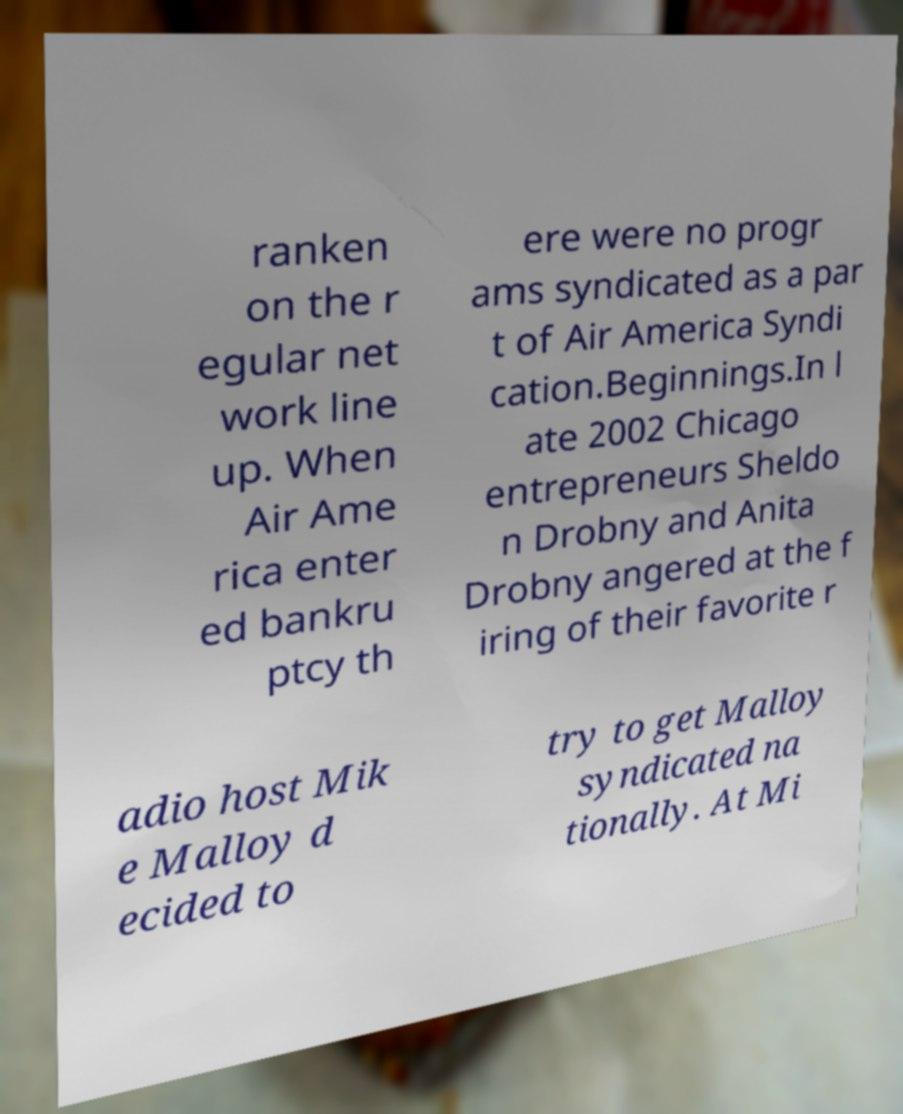For documentation purposes, I need the text within this image transcribed. Could you provide that? ranken on the r egular net work line up. When Air Ame rica enter ed bankru ptcy th ere were no progr ams syndicated as a par t of Air America Syndi cation.Beginnings.In l ate 2002 Chicago entrepreneurs Sheldo n Drobny and Anita Drobny angered at the f iring of their favorite r adio host Mik e Malloy d ecided to try to get Malloy syndicated na tionally. At Mi 